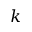Convert formula to latex. <formula><loc_0><loc_0><loc_500><loc_500>k</formula> 